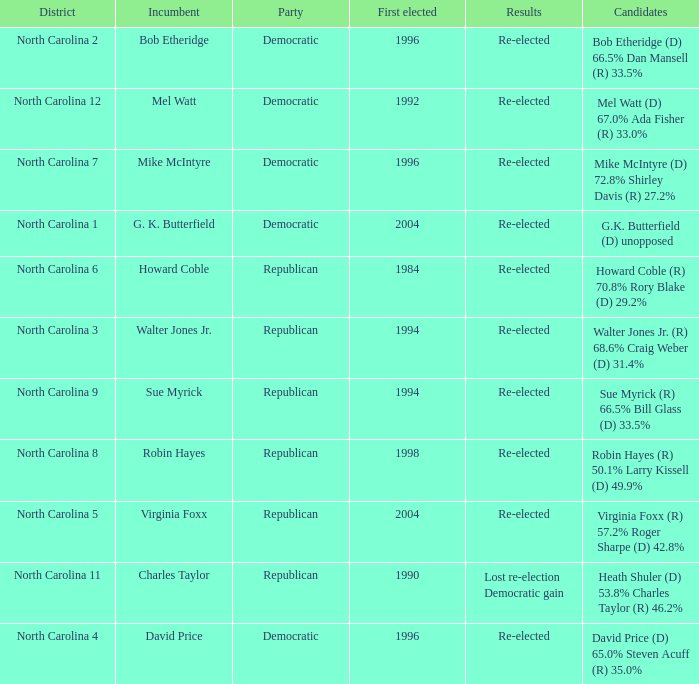How many times did Robin Hayes run? 1.0. 